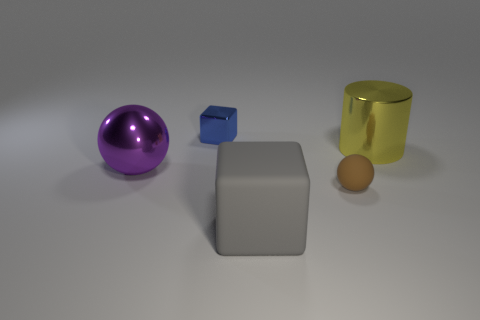Add 5 brown rubber spheres. How many objects exist? 10 Add 5 blue metallic cubes. How many blue metallic cubes are left? 6 Add 2 purple metal balls. How many purple metal balls exist? 3 Subtract 0 red cubes. How many objects are left? 5 Subtract all spheres. How many objects are left? 3 Subtract all purple cylinders. Subtract all red spheres. How many cylinders are left? 1 Subtract all red metal cylinders. Subtract all large cylinders. How many objects are left? 4 